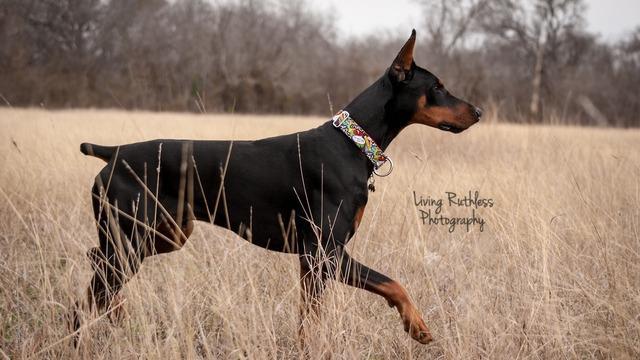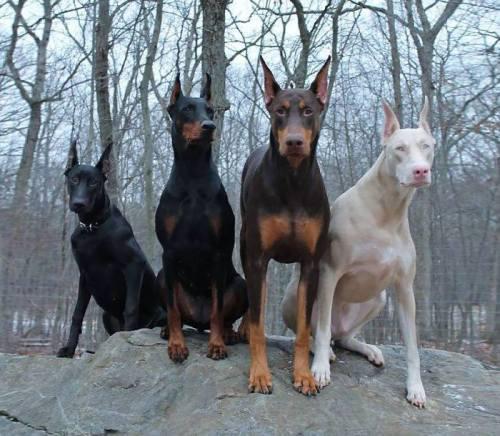The first image is the image on the left, the second image is the image on the right. Evaluate the accuracy of this statement regarding the images: "A dog in one of the images is solid white, and one dog has a very visible collar.". Is it true? Answer yes or no. Yes. 